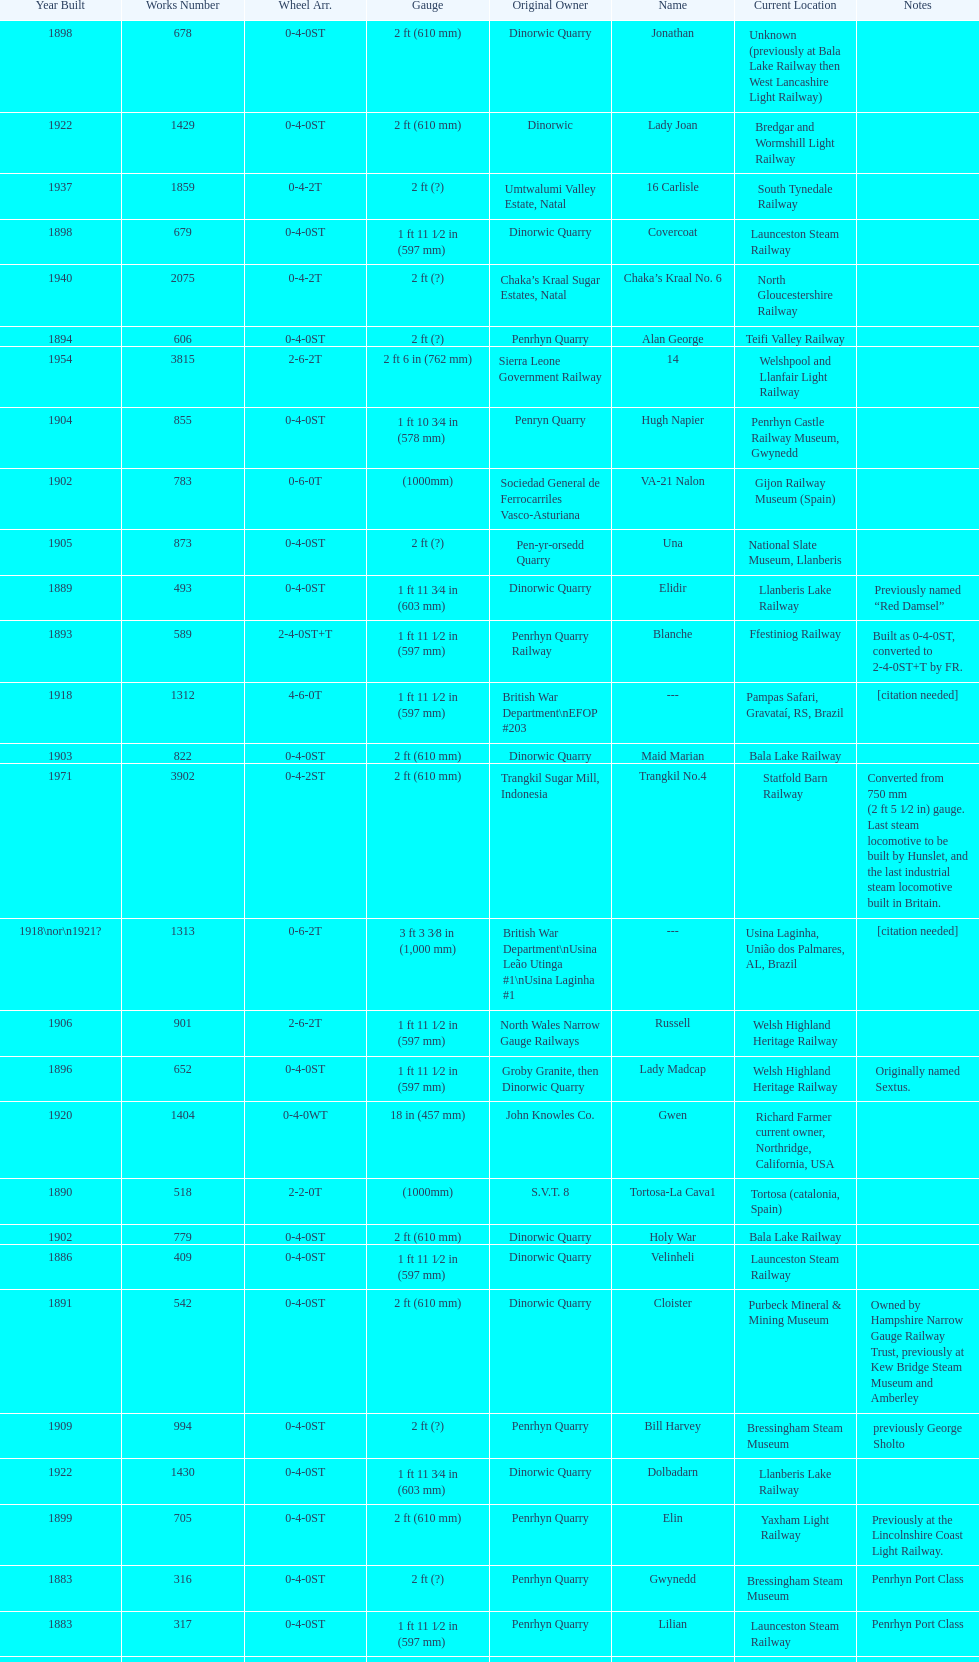What is the total number of preserved hunslet narrow gauge locomotives currently located in ffestiniog railway 554. 